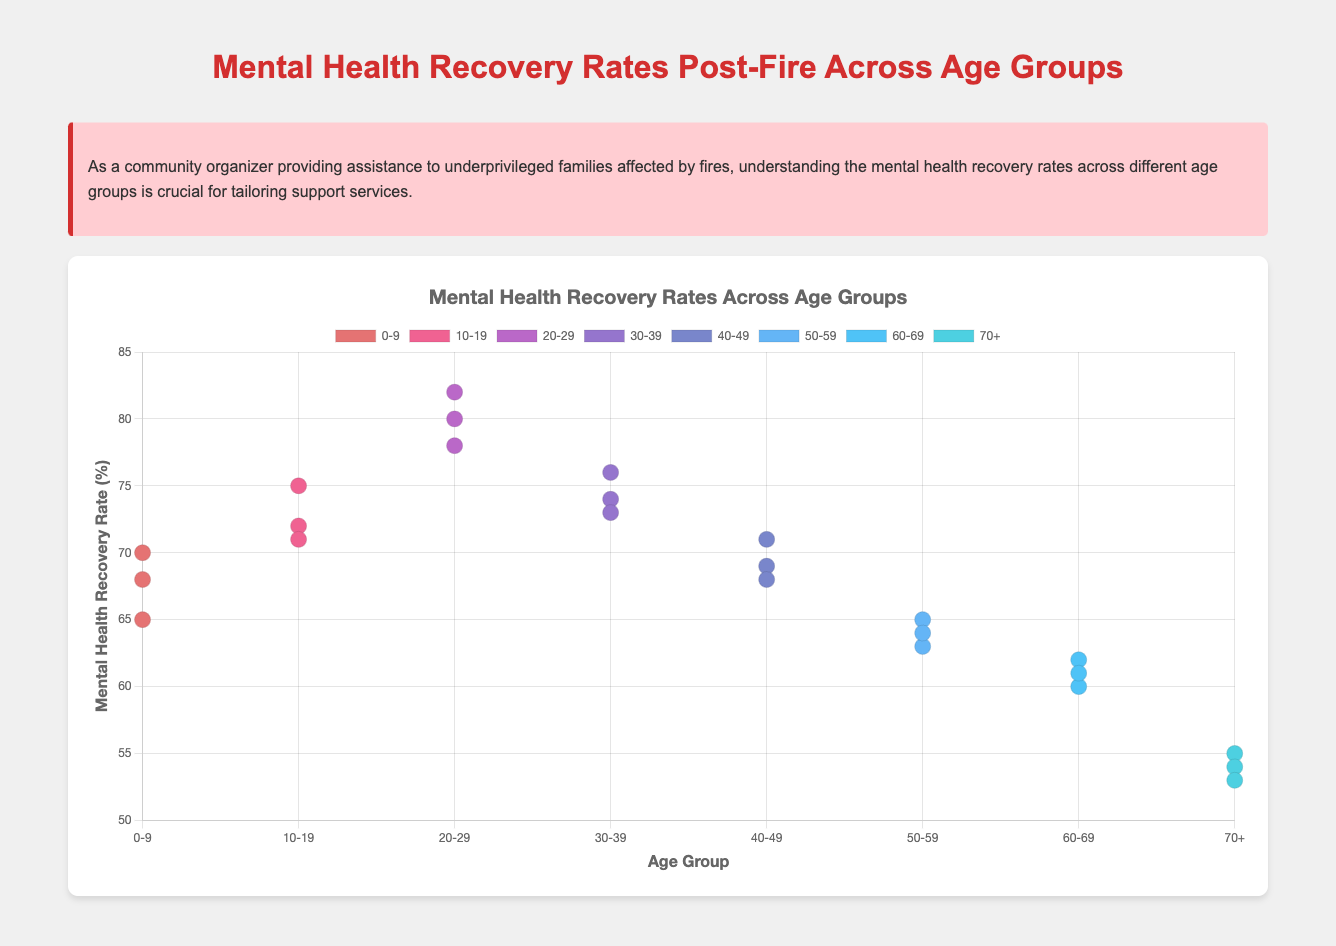What is the title of the scatter plot? The title of the scatter plot is usually prominently displayed at the top of the chart. In this case, the title is "Mental Health Recovery Rates Across Age Groups" as provided in the code.
Answer: Mental Health Recovery Rates Across Age Groups What are the age groups represented in the scatter plot? The age groups can be identified by their labels on the x-axis and the dataset labels in the figure. The age groups represented are "0-9", "10-19", "20-29", "30-39", "40-49", "50-59", "60-69", and "70+".
Answer: 0-9, 10-19, 20-29, 30-39, 40-49, 50-59, 60-69, 70+ Which age group has the highest mental health recovery rate? Look at the y-axis, which shows the mental health recovery rates, and identify the point or group with the highest value. The age group "20-29" has the highest recovery rate at 82%.
Answer: 20-29 What is the minimum recovery rate recorded among all age groups? The minimum recovery rate can be found by looking at the lowest point on the y-axis. The 70+ age group has a minimum recovery rate of 53%.
Answer: 53% How does the mental health recovery rate trend with increasing age? By looking at the trend line and data points distribution, we can observe that the recovery rates generally decrease with increasing age, showing a downward trend.
Answer: Decreases What is the average mental health recovery rate for the age group 50-59? To calculate the average, sum the recovery rates for the age group 50-59 and then divide by the number of data points: (63 + 65 + 64) / 3 = 64.
Answer: 64 Compare the recovery rates between age groups 0-9 and 60-69. Which has a higher average recovery rate? Calculate the average recovery rate for each group. For 0-9, it is (65 + 70 + 68) / 3 = 67.67. For 60-69, it is (62 + 60 + 61) / 3 = 61. Therefore, the 0-9 age group has a higher average recovery rate.
Answer: 0-9 What is the difference in recovery rates between the highest and lowest rates recorded? Identify the highest and lowest rates: 82 for 20-29 and 53 for 70+. The difference is 82 - 53 = 29.
Answer: 29 Identify the trend line direction in the scatter plot. Is it generally upwards or downwards? From the trend line, we can observe whether the plot shows an increasing or decreasing pattern. The trend line in this scatter plot is generally downwards, indicating decreasing recovery rates with age.
Answer: Downwards What is the recovery rate for the age group 10-19 that is highest? Look at the points plotted for the age group 10-19 and identify the highest value which is 75%.
Answer: 75 